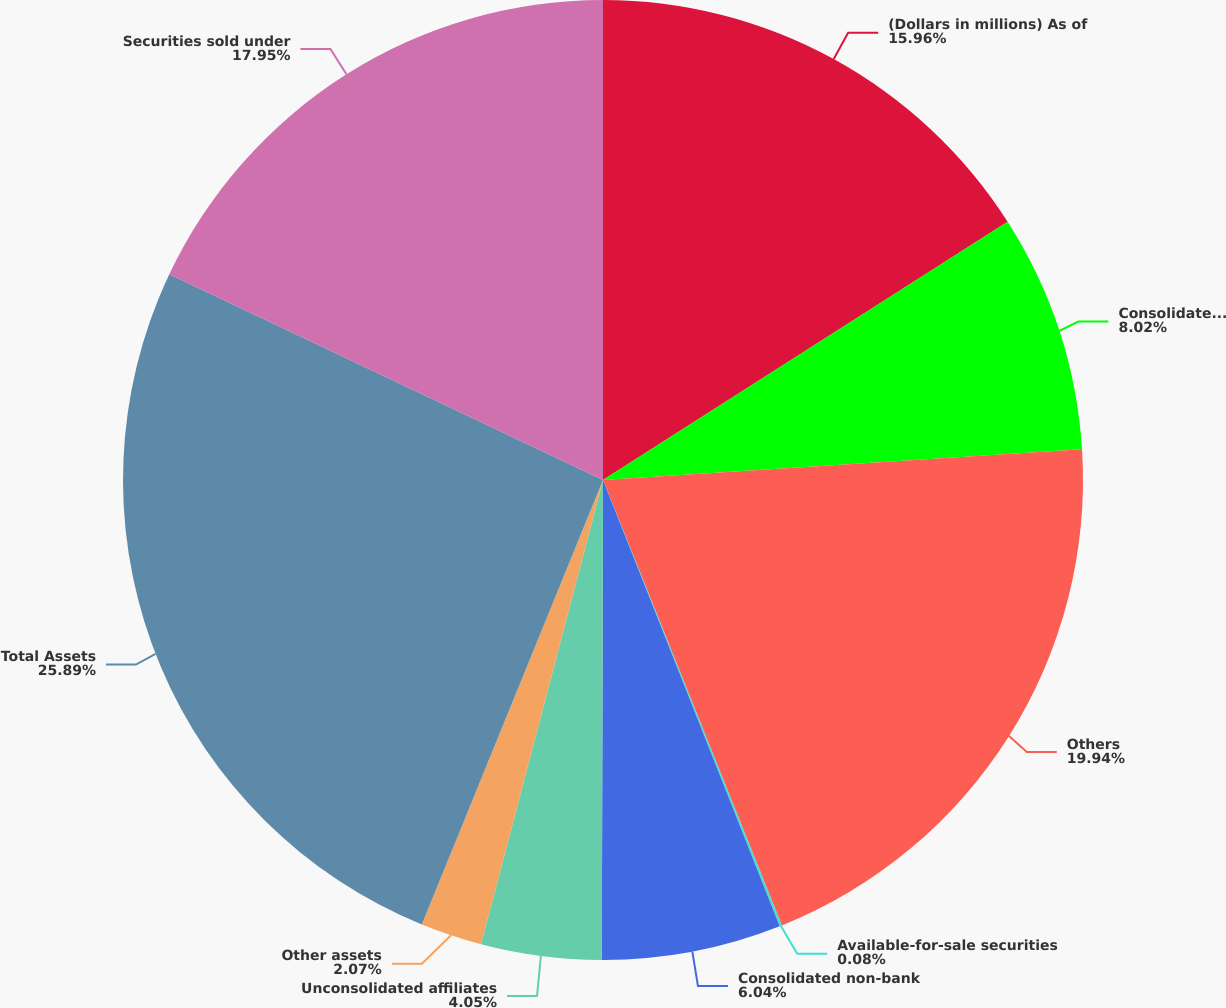Convert chart. <chart><loc_0><loc_0><loc_500><loc_500><pie_chart><fcel>(Dollars in millions) As of<fcel>Consolidated bank subsidiary<fcel>Others<fcel>Available-for-sale securities<fcel>Consolidated non-bank<fcel>Unconsolidated affiliates<fcel>Other assets<fcel>Total Assets<fcel>Securities sold under<nl><fcel>15.96%<fcel>8.02%<fcel>19.94%<fcel>0.08%<fcel>6.04%<fcel>4.05%<fcel>2.07%<fcel>25.89%<fcel>17.95%<nl></chart> 